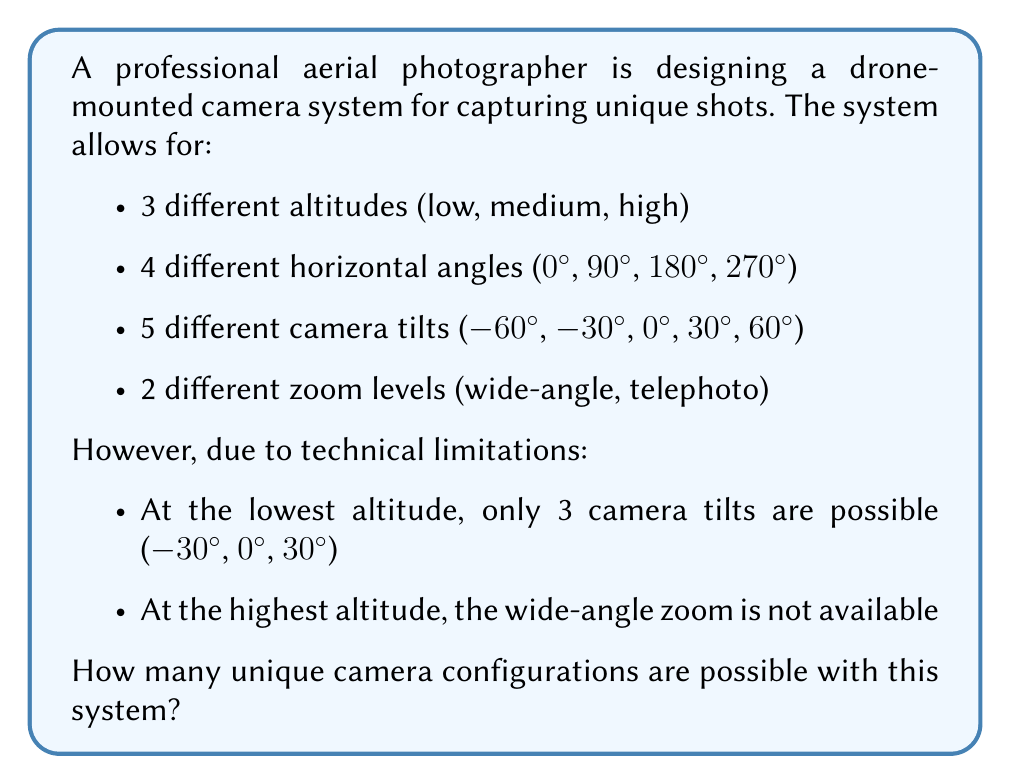Solve this math problem. Let's break this down step-by-step using the multiplication principle of counting:

1) For medium altitude:
   - 4 horizontal angles
   - 5 camera tilts
   - 2 zoom levels
   Total for medium altitude: $4 \times 5 \times 2 = 40$ configurations

2) For lowest altitude:
   - 4 horizontal angles
   - 3 camera tilts (restricted)
   - 2 zoom levels
   Total for lowest altitude: $4 \times 3 \times 2 = 24$ configurations

3) For highest altitude:
   - 4 horizontal angles
   - 5 camera tilts
   - 1 zoom level (restricted)
   Total for highest altitude: $4 \times 5 \times 1 = 20$ configurations

Now, we sum up the configurations for all altitudes:

$$\text{Total configurations} = 40 + 24 + 20 = 84$$

Therefore, there are 84 unique camera configurations possible with this system.
Answer: 84 unique camera configurations 